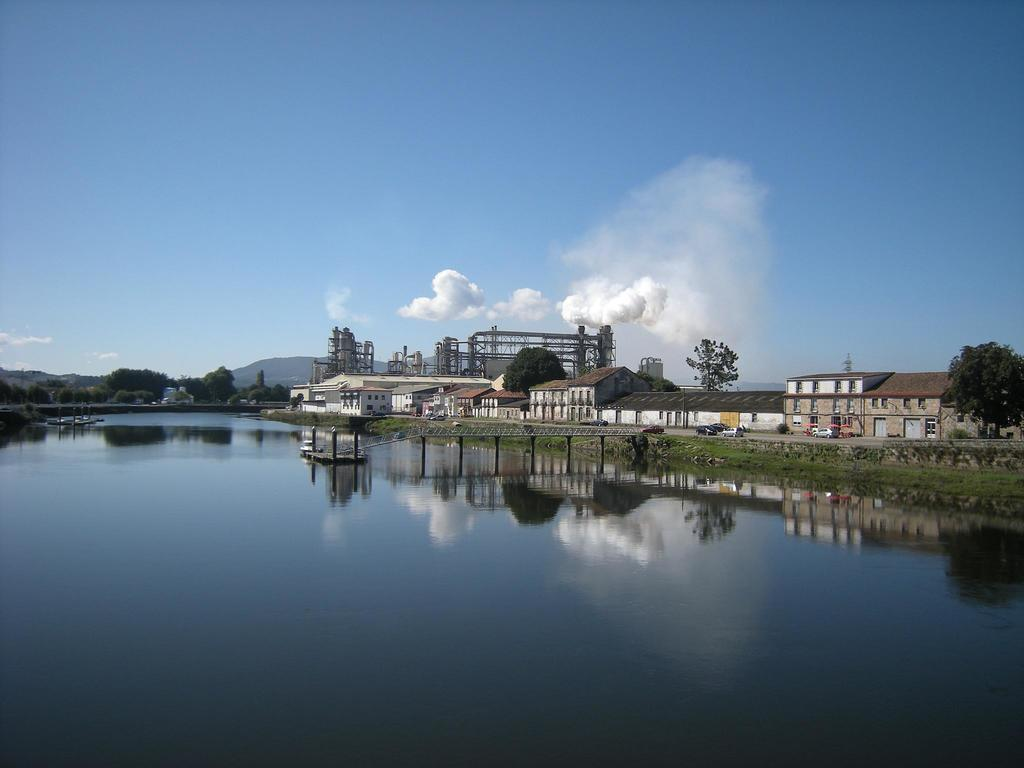What type of structures can be seen in the image? There are buildings in the image. What connects the two sides of the water in the image? There is a bridge in the image. What is under the bridge in the image? Water is visible under the bridge. What is moving on the road in the image? There are vehicles present on the road in the image. What type of vegetation can be seen in the image? There are trees in the image. What can be seen in the distance in the image? Mountains are visible in the background of the image, and the sky is also visible. What type of flag is waving on the street in the image? There is no flag present on the street in the image. What type of bulb is illuminating the bridge in the image? There is no bulb present on the bridge in the image. 